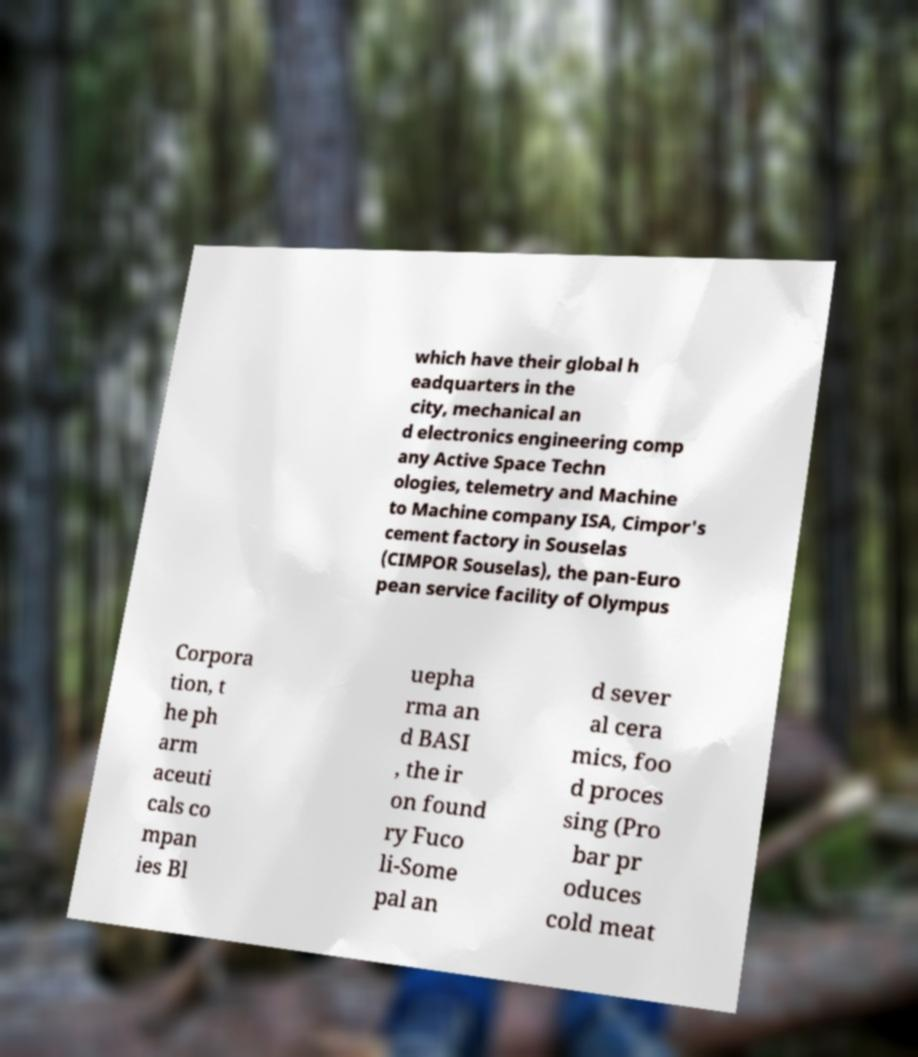Please read and relay the text visible in this image. What does it say? which have their global h eadquarters in the city, mechanical an d electronics engineering comp any Active Space Techn ologies, telemetry and Machine to Machine company ISA, Cimpor's cement factory in Souselas (CIMPOR Souselas), the pan-Euro pean service facility of Olympus Corpora tion, t he ph arm aceuti cals co mpan ies Bl uepha rma an d BASI , the ir on found ry Fuco li-Some pal an d sever al cera mics, foo d proces sing (Pro bar pr oduces cold meat 